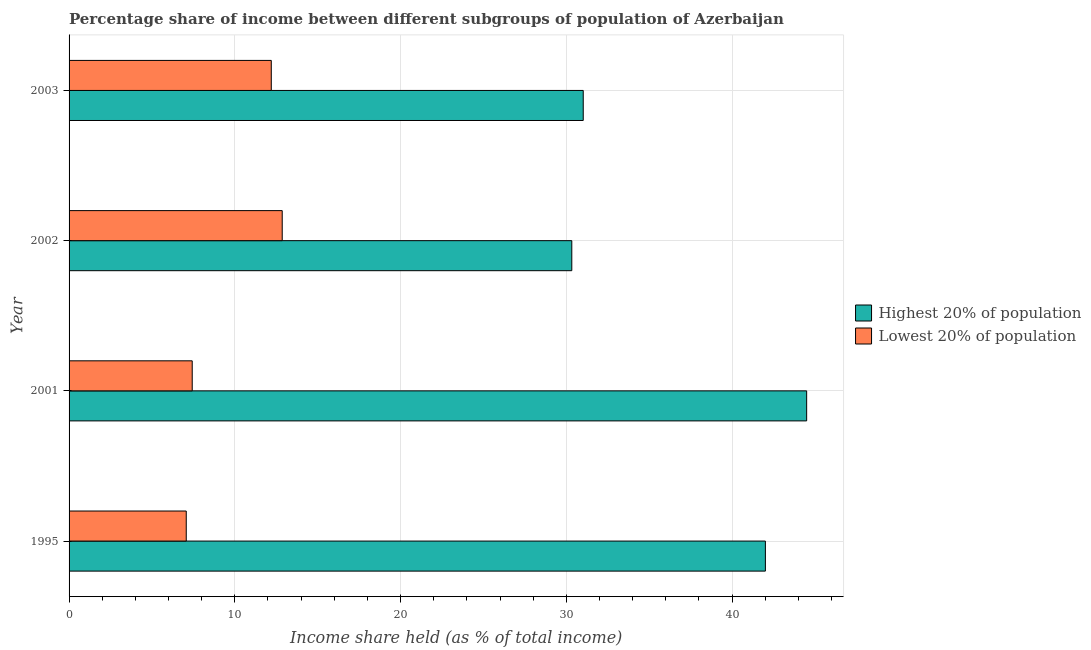How many different coloured bars are there?
Your answer should be very brief. 2. Are the number of bars on each tick of the Y-axis equal?
Your response must be concise. Yes. What is the label of the 3rd group of bars from the top?
Provide a succinct answer. 2001. In how many cases, is the number of bars for a given year not equal to the number of legend labels?
Provide a short and direct response. 0. What is the income share held by lowest 20% of the population in 2002?
Provide a short and direct response. 12.86. Across all years, what is the maximum income share held by lowest 20% of the population?
Make the answer very short. 12.86. Across all years, what is the minimum income share held by lowest 20% of the population?
Give a very brief answer. 7.07. In which year was the income share held by lowest 20% of the population minimum?
Provide a succinct answer. 1995. What is the total income share held by lowest 20% of the population in the graph?
Keep it short and to the point. 39.56. What is the difference between the income share held by highest 20% of the population in 2001 and that in 2003?
Your answer should be compact. 13.48. What is the difference between the income share held by highest 20% of the population in 2002 and the income share held by lowest 20% of the population in 2001?
Provide a short and direct response. 22.9. What is the average income share held by highest 20% of the population per year?
Your answer should be compact. 36.97. In the year 2002, what is the difference between the income share held by highest 20% of the population and income share held by lowest 20% of the population?
Your response must be concise. 17.47. What is the ratio of the income share held by lowest 20% of the population in 1995 to that in 2003?
Provide a succinct answer. 0.58. Is the income share held by highest 20% of the population in 2001 less than that in 2003?
Ensure brevity in your answer.  No. What is the difference between the highest and the second highest income share held by lowest 20% of the population?
Provide a short and direct response. 0.66. What is the difference between the highest and the lowest income share held by highest 20% of the population?
Your answer should be very brief. 14.17. In how many years, is the income share held by lowest 20% of the population greater than the average income share held by lowest 20% of the population taken over all years?
Offer a terse response. 2. Is the sum of the income share held by lowest 20% of the population in 2001 and 2002 greater than the maximum income share held by highest 20% of the population across all years?
Ensure brevity in your answer.  No. What does the 1st bar from the top in 2003 represents?
Give a very brief answer. Lowest 20% of population. What does the 2nd bar from the bottom in 2003 represents?
Give a very brief answer. Lowest 20% of population. How many bars are there?
Your response must be concise. 8. Are all the bars in the graph horizontal?
Your answer should be compact. Yes. What is the difference between two consecutive major ticks on the X-axis?
Your response must be concise. 10. Does the graph contain any zero values?
Offer a very short reply. No. What is the title of the graph?
Your answer should be compact. Percentage share of income between different subgroups of population of Azerbaijan. Does "Highest 20% of population" appear as one of the legend labels in the graph?
Give a very brief answer. Yes. What is the label or title of the X-axis?
Your answer should be very brief. Income share held (as % of total income). What is the label or title of the Y-axis?
Your answer should be compact. Year. What is the Income share held (as % of total income) in Highest 20% of population in 1995?
Keep it short and to the point. 42.01. What is the Income share held (as % of total income) in Lowest 20% of population in 1995?
Provide a short and direct response. 7.07. What is the Income share held (as % of total income) in Highest 20% of population in 2001?
Offer a very short reply. 44.5. What is the Income share held (as % of total income) in Lowest 20% of population in 2001?
Offer a terse response. 7.43. What is the Income share held (as % of total income) in Highest 20% of population in 2002?
Give a very brief answer. 30.33. What is the Income share held (as % of total income) in Lowest 20% of population in 2002?
Provide a short and direct response. 12.86. What is the Income share held (as % of total income) in Highest 20% of population in 2003?
Your answer should be compact. 31.02. What is the Income share held (as % of total income) in Lowest 20% of population in 2003?
Offer a terse response. 12.2. Across all years, what is the maximum Income share held (as % of total income) in Highest 20% of population?
Offer a very short reply. 44.5. Across all years, what is the maximum Income share held (as % of total income) of Lowest 20% of population?
Make the answer very short. 12.86. Across all years, what is the minimum Income share held (as % of total income) of Highest 20% of population?
Provide a succinct answer. 30.33. Across all years, what is the minimum Income share held (as % of total income) in Lowest 20% of population?
Your response must be concise. 7.07. What is the total Income share held (as % of total income) in Highest 20% of population in the graph?
Provide a succinct answer. 147.86. What is the total Income share held (as % of total income) in Lowest 20% of population in the graph?
Offer a very short reply. 39.56. What is the difference between the Income share held (as % of total income) in Highest 20% of population in 1995 and that in 2001?
Ensure brevity in your answer.  -2.49. What is the difference between the Income share held (as % of total income) of Lowest 20% of population in 1995 and that in 2001?
Offer a terse response. -0.36. What is the difference between the Income share held (as % of total income) of Highest 20% of population in 1995 and that in 2002?
Give a very brief answer. 11.68. What is the difference between the Income share held (as % of total income) of Lowest 20% of population in 1995 and that in 2002?
Offer a very short reply. -5.79. What is the difference between the Income share held (as % of total income) of Highest 20% of population in 1995 and that in 2003?
Your answer should be very brief. 10.99. What is the difference between the Income share held (as % of total income) in Lowest 20% of population in 1995 and that in 2003?
Your answer should be very brief. -5.13. What is the difference between the Income share held (as % of total income) of Highest 20% of population in 2001 and that in 2002?
Your answer should be very brief. 14.17. What is the difference between the Income share held (as % of total income) in Lowest 20% of population in 2001 and that in 2002?
Your answer should be very brief. -5.43. What is the difference between the Income share held (as % of total income) of Highest 20% of population in 2001 and that in 2003?
Ensure brevity in your answer.  13.48. What is the difference between the Income share held (as % of total income) in Lowest 20% of population in 2001 and that in 2003?
Your answer should be very brief. -4.77. What is the difference between the Income share held (as % of total income) in Highest 20% of population in 2002 and that in 2003?
Make the answer very short. -0.69. What is the difference between the Income share held (as % of total income) in Lowest 20% of population in 2002 and that in 2003?
Offer a terse response. 0.66. What is the difference between the Income share held (as % of total income) in Highest 20% of population in 1995 and the Income share held (as % of total income) in Lowest 20% of population in 2001?
Make the answer very short. 34.58. What is the difference between the Income share held (as % of total income) in Highest 20% of population in 1995 and the Income share held (as % of total income) in Lowest 20% of population in 2002?
Offer a very short reply. 29.15. What is the difference between the Income share held (as % of total income) of Highest 20% of population in 1995 and the Income share held (as % of total income) of Lowest 20% of population in 2003?
Your answer should be compact. 29.81. What is the difference between the Income share held (as % of total income) in Highest 20% of population in 2001 and the Income share held (as % of total income) in Lowest 20% of population in 2002?
Provide a succinct answer. 31.64. What is the difference between the Income share held (as % of total income) in Highest 20% of population in 2001 and the Income share held (as % of total income) in Lowest 20% of population in 2003?
Your response must be concise. 32.3. What is the difference between the Income share held (as % of total income) of Highest 20% of population in 2002 and the Income share held (as % of total income) of Lowest 20% of population in 2003?
Ensure brevity in your answer.  18.13. What is the average Income share held (as % of total income) in Highest 20% of population per year?
Provide a succinct answer. 36.97. What is the average Income share held (as % of total income) in Lowest 20% of population per year?
Your answer should be compact. 9.89. In the year 1995, what is the difference between the Income share held (as % of total income) of Highest 20% of population and Income share held (as % of total income) of Lowest 20% of population?
Provide a short and direct response. 34.94. In the year 2001, what is the difference between the Income share held (as % of total income) of Highest 20% of population and Income share held (as % of total income) of Lowest 20% of population?
Keep it short and to the point. 37.07. In the year 2002, what is the difference between the Income share held (as % of total income) of Highest 20% of population and Income share held (as % of total income) of Lowest 20% of population?
Your answer should be very brief. 17.47. In the year 2003, what is the difference between the Income share held (as % of total income) in Highest 20% of population and Income share held (as % of total income) in Lowest 20% of population?
Offer a very short reply. 18.82. What is the ratio of the Income share held (as % of total income) of Highest 20% of population in 1995 to that in 2001?
Your answer should be very brief. 0.94. What is the ratio of the Income share held (as % of total income) of Lowest 20% of population in 1995 to that in 2001?
Offer a terse response. 0.95. What is the ratio of the Income share held (as % of total income) of Highest 20% of population in 1995 to that in 2002?
Provide a short and direct response. 1.39. What is the ratio of the Income share held (as % of total income) of Lowest 20% of population in 1995 to that in 2002?
Provide a succinct answer. 0.55. What is the ratio of the Income share held (as % of total income) of Highest 20% of population in 1995 to that in 2003?
Provide a succinct answer. 1.35. What is the ratio of the Income share held (as % of total income) of Lowest 20% of population in 1995 to that in 2003?
Your response must be concise. 0.58. What is the ratio of the Income share held (as % of total income) of Highest 20% of population in 2001 to that in 2002?
Give a very brief answer. 1.47. What is the ratio of the Income share held (as % of total income) in Lowest 20% of population in 2001 to that in 2002?
Give a very brief answer. 0.58. What is the ratio of the Income share held (as % of total income) of Highest 20% of population in 2001 to that in 2003?
Your answer should be very brief. 1.43. What is the ratio of the Income share held (as % of total income) of Lowest 20% of population in 2001 to that in 2003?
Provide a short and direct response. 0.61. What is the ratio of the Income share held (as % of total income) of Highest 20% of population in 2002 to that in 2003?
Your answer should be very brief. 0.98. What is the ratio of the Income share held (as % of total income) in Lowest 20% of population in 2002 to that in 2003?
Keep it short and to the point. 1.05. What is the difference between the highest and the second highest Income share held (as % of total income) in Highest 20% of population?
Your response must be concise. 2.49. What is the difference between the highest and the second highest Income share held (as % of total income) in Lowest 20% of population?
Your answer should be very brief. 0.66. What is the difference between the highest and the lowest Income share held (as % of total income) of Highest 20% of population?
Keep it short and to the point. 14.17. What is the difference between the highest and the lowest Income share held (as % of total income) of Lowest 20% of population?
Keep it short and to the point. 5.79. 